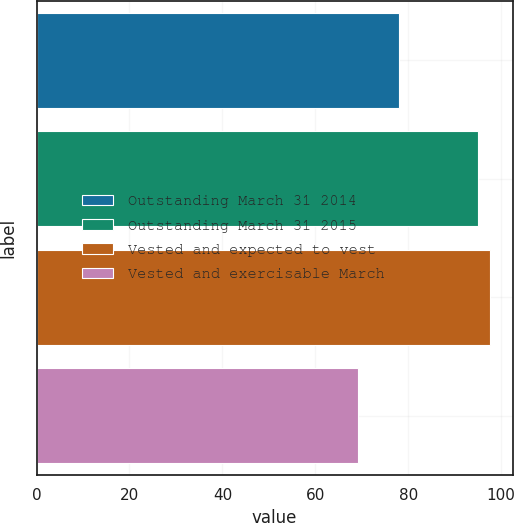<chart> <loc_0><loc_0><loc_500><loc_500><bar_chart><fcel>Outstanding March 31 2014<fcel>Outstanding March 31 2015<fcel>Vested and expected to vest<fcel>Vested and exercisable March<nl><fcel>78.07<fcel>95.01<fcel>97.58<fcel>69.27<nl></chart> 